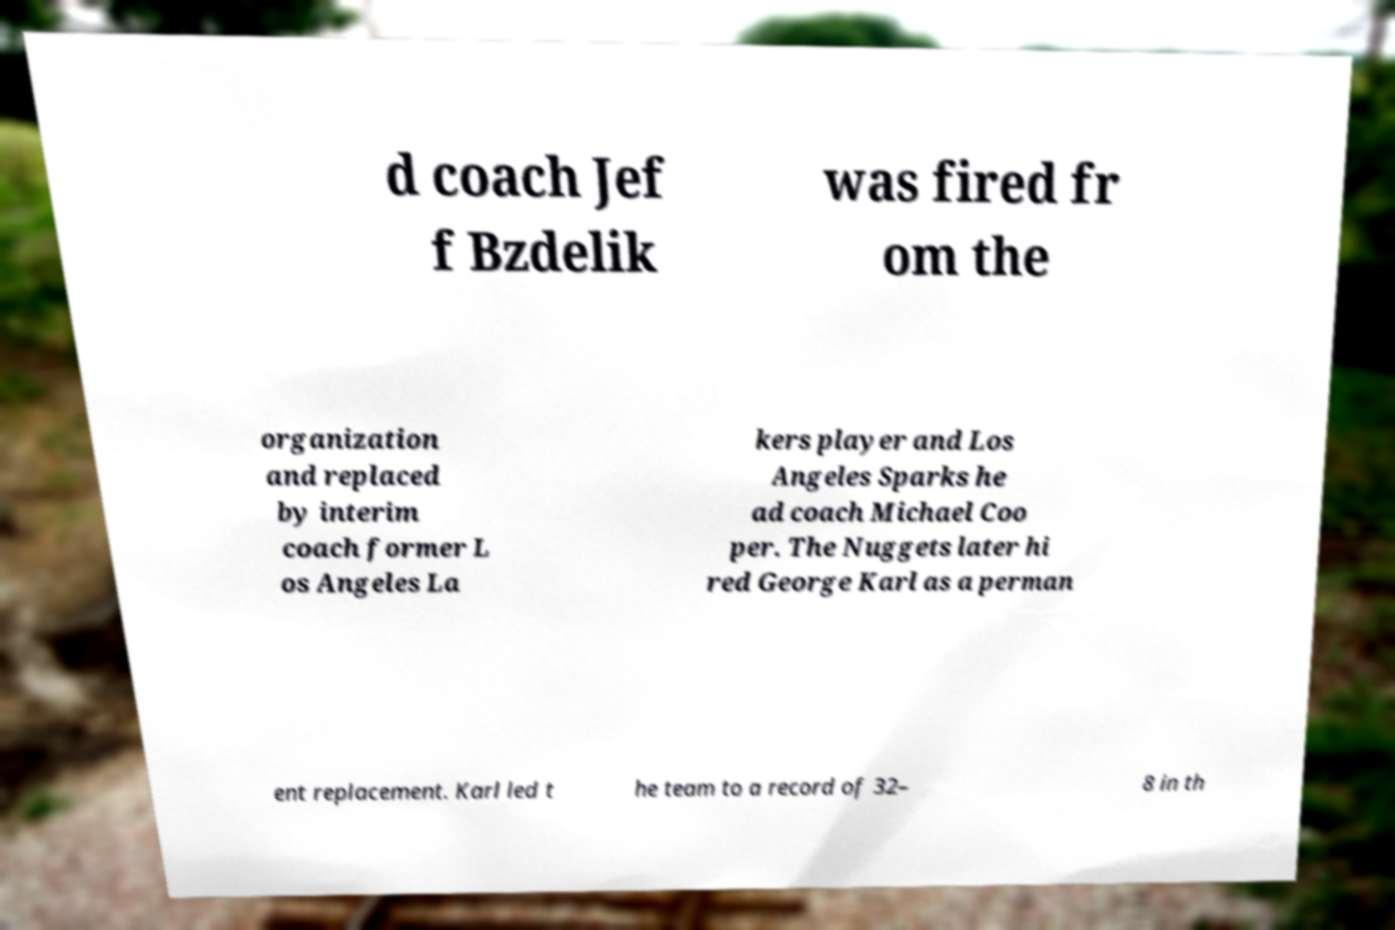I need the written content from this picture converted into text. Can you do that? d coach Jef f Bzdelik was fired fr om the organization and replaced by interim coach former L os Angeles La kers player and Los Angeles Sparks he ad coach Michael Coo per. The Nuggets later hi red George Karl as a perman ent replacement. Karl led t he team to a record of 32– 8 in th 